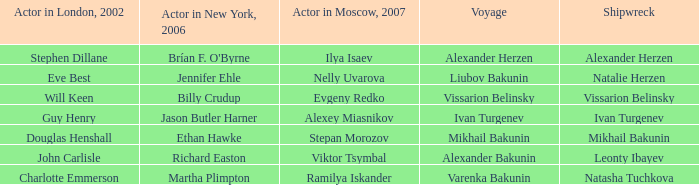Who was the 2007 thespian from moscow for the expedition of varenka bakunin? Ramilya Iskander. 